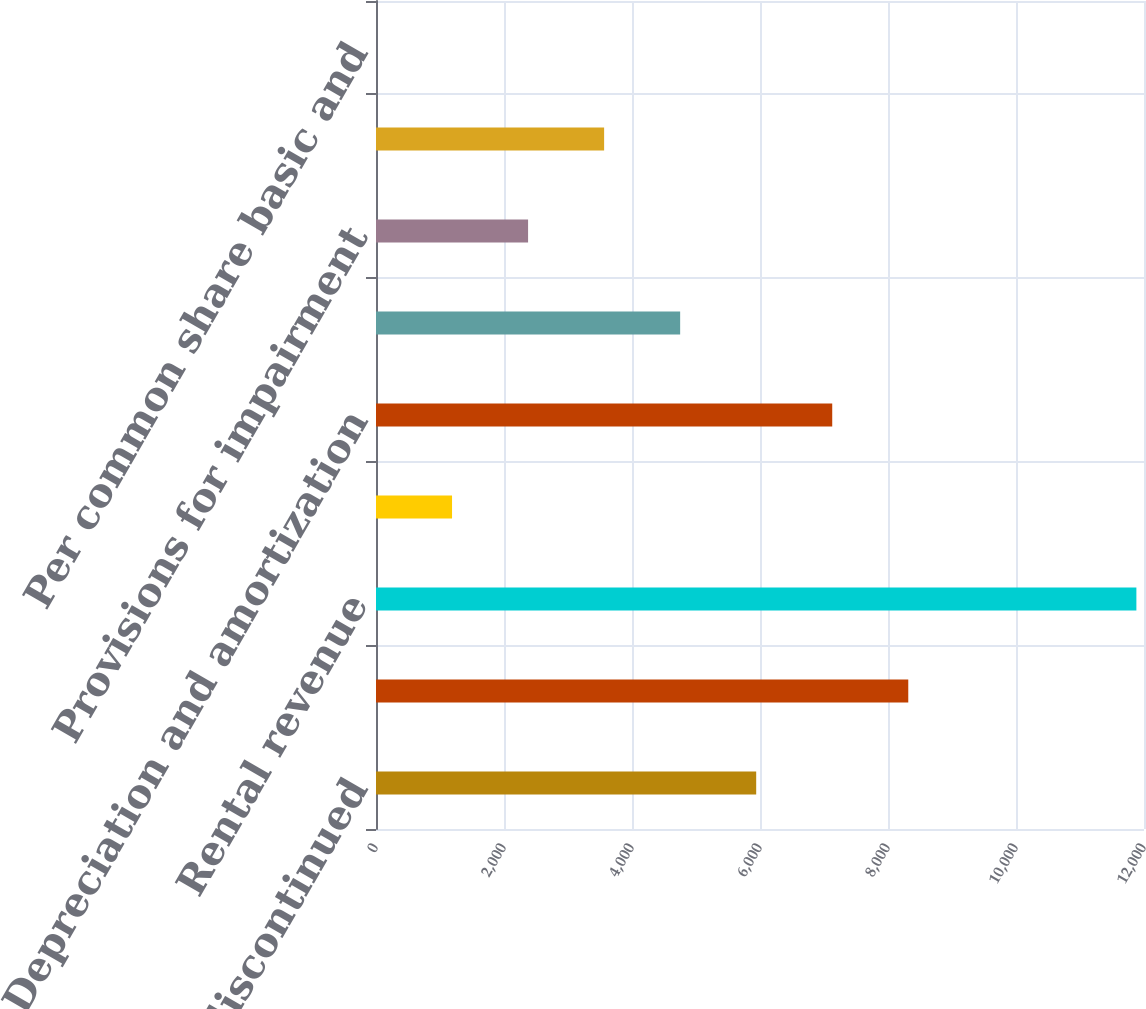Convert chart to OTSL. <chart><loc_0><loc_0><loc_500><loc_500><bar_chart><fcel>Income from discontinued<fcel>Gain on sales of investment<fcel>Rental revenue<fcel>Other revenue<fcel>Depreciation and amortization<fcel>Property expenses<fcel>Provisions for impairment<fcel>Crest's income from<fcel>Per common share basic and<nl><fcel>5940.55<fcel>8316.73<fcel>11881<fcel>1188.19<fcel>7128.64<fcel>4752.46<fcel>2376.28<fcel>3564.37<fcel>0.1<nl></chart> 